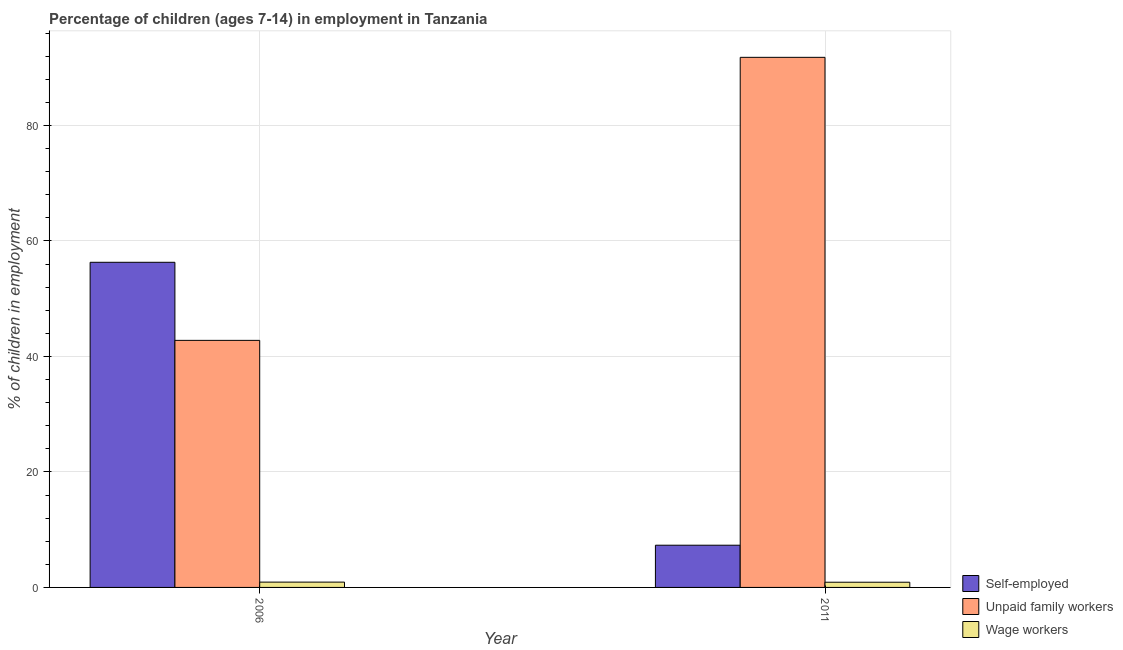How many different coloured bars are there?
Your response must be concise. 3. How many groups of bars are there?
Give a very brief answer. 2. Are the number of bars per tick equal to the number of legend labels?
Your answer should be compact. Yes. What is the label of the 1st group of bars from the left?
Your answer should be compact. 2006. In how many cases, is the number of bars for a given year not equal to the number of legend labels?
Your answer should be very brief. 0. What is the percentage of children employed as wage workers in 2011?
Your answer should be very brief. 0.9. Across all years, what is the maximum percentage of children employed as wage workers?
Your response must be concise. 0.92. Across all years, what is the minimum percentage of self employed children?
Give a very brief answer. 7.31. In which year was the percentage of children employed as unpaid family workers maximum?
Ensure brevity in your answer.  2011. What is the total percentage of children employed as unpaid family workers in the graph?
Keep it short and to the point. 134.57. What is the difference between the percentage of children employed as unpaid family workers in 2006 and that in 2011?
Provide a short and direct response. -49.01. What is the difference between the percentage of children employed as unpaid family workers in 2011 and the percentage of self employed children in 2006?
Offer a terse response. 49.01. What is the average percentage of children employed as wage workers per year?
Your answer should be compact. 0.91. In how many years, is the percentage of children employed as unpaid family workers greater than 72 %?
Give a very brief answer. 1. What is the ratio of the percentage of children employed as unpaid family workers in 2006 to that in 2011?
Offer a terse response. 0.47. What does the 1st bar from the left in 2011 represents?
Give a very brief answer. Self-employed. What does the 2nd bar from the right in 2006 represents?
Keep it short and to the point. Unpaid family workers. Is it the case that in every year, the sum of the percentage of self employed children and percentage of children employed as unpaid family workers is greater than the percentage of children employed as wage workers?
Ensure brevity in your answer.  Yes. Are all the bars in the graph horizontal?
Your answer should be very brief. No. What is the difference between two consecutive major ticks on the Y-axis?
Make the answer very short. 20. How are the legend labels stacked?
Give a very brief answer. Vertical. What is the title of the graph?
Ensure brevity in your answer.  Percentage of children (ages 7-14) in employment in Tanzania. Does "Industry" appear as one of the legend labels in the graph?
Ensure brevity in your answer.  No. What is the label or title of the X-axis?
Your response must be concise. Year. What is the label or title of the Y-axis?
Your response must be concise. % of children in employment. What is the % of children in employment in Self-employed in 2006?
Offer a very short reply. 56.3. What is the % of children in employment in Unpaid family workers in 2006?
Keep it short and to the point. 42.78. What is the % of children in employment of Wage workers in 2006?
Make the answer very short. 0.92. What is the % of children in employment of Self-employed in 2011?
Keep it short and to the point. 7.31. What is the % of children in employment in Unpaid family workers in 2011?
Ensure brevity in your answer.  91.79. What is the % of children in employment of Wage workers in 2011?
Your response must be concise. 0.9. Across all years, what is the maximum % of children in employment in Self-employed?
Provide a succinct answer. 56.3. Across all years, what is the maximum % of children in employment in Unpaid family workers?
Your answer should be very brief. 91.79. Across all years, what is the maximum % of children in employment in Wage workers?
Your response must be concise. 0.92. Across all years, what is the minimum % of children in employment in Self-employed?
Ensure brevity in your answer.  7.31. Across all years, what is the minimum % of children in employment in Unpaid family workers?
Provide a succinct answer. 42.78. Across all years, what is the minimum % of children in employment of Wage workers?
Your response must be concise. 0.9. What is the total % of children in employment of Self-employed in the graph?
Ensure brevity in your answer.  63.61. What is the total % of children in employment in Unpaid family workers in the graph?
Provide a succinct answer. 134.57. What is the total % of children in employment in Wage workers in the graph?
Your response must be concise. 1.82. What is the difference between the % of children in employment in Self-employed in 2006 and that in 2011?
Give a very brief answer. 48.99. What is the difference between the % of children in employment of Unpaid family workers in 2006 and that in 2011?
Offer a very short reply. -49.01. What is the difference between the % of children in employment in Wage workers in 2006 and that in 2011?
Your answer should be compact. 0.02. What is the difference between the % of children in employment of Self-employed in 2006 and the % of children in employment of Unpaid family workers in 2011?
Keep it short and to the point. -35.49. What is the difference between the % of children in employment of Self-employed in 2006 and the % of children in employment of Wage workers in 2011?
Your answer should be very brief. 55.4. What is the difference between the % of children in employment in Unpaid family workers in 2006 and the % of children in employment in Wage workers in 2011?
Offer a very short reply. 41.88. What is the average % of children in employment of Self-employed per year?
Provide a short and direct response. 31.8. What is the average % of children in employment in Unpaid family workers per year?
Your response must be concise. 67.28. What is the average % of children in employment in Wage workers per year?
Provide a short and direct response. 0.91. In the year 2006, what is the difference between the % of children in employment in Self-employed and % of children in employment in Unpaid family workers?
Give a very brief answer. 13.52. In the year 2006, what is the difference between the % of children in employment in Self-employed and % of children in employment in Wage workers?
Offer a very short reply. 55.38. In the year 2006, what is the difference between the % of children in employment of Unpaid family workers and % of children in employment of Wage workers?
Offer a very short reply. 41.86. In the year 2011, what is the difference between the % of children in employment of Self-employed and % of children in employment of Unpaid family workers?
Make the answer very short. -84.48. In the year 2011, what is the difference between the % of children in employment of Self-employed and % of children in employment of Wage workers?
Offer a very short reply. 6.41. In the year 2011, what is the difference between the % of children in employment of Unpaid family workers and % of children in employment of Wage workers?
Give a very brief answer. 90.89. What is the ratio of the % of children in employment in Self-employed in 2006 to that in 2011?
Make the answer very short. 7.7. What is the ratio of the % of children in employment of Unpaid family workers in 2006 to that in 2011?
Offer a terse response. 0.47. What is the ratio of the % of children in employment in Wage workers in 2006 to that in 2011?
Ensure brevity in your answer.  1.02. What is the difference between the highest and the second highest % of children in employment of Self-employed?
Give a very brief answer. 48.99. What is the difference between the highest and the second highest % of children in employment in Unpaid family workers?
Offer a terse response. 49.01. What is the difference between the highest and the second highest % of children in employment of Wage workers?
Your answer should be compact. 0.02. What is the difference between the highest and the lowest % of children in employment in Self-employed?
Offer a very short reply. 48.99. What is the difference between the highest and the lowest % of children in employment of Unpaid family workers?
Make the answer very short. 49.01. 